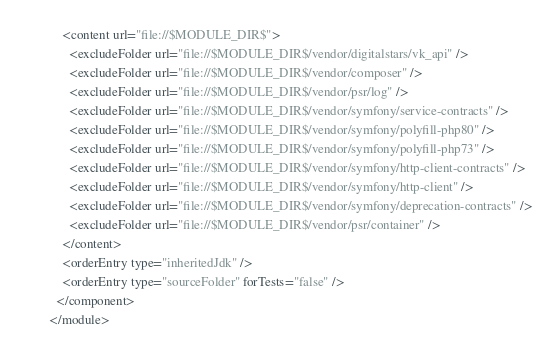Convert code to text. <code><loc_0><loc_0><loc_500><loc_500><_XML_>    <content url="file://$MODULE_DIR$">
      <excludeFolder url="file://$MODULE_DIR$/vendor/digitalstars/vk_api" />
      <excludeFolder url="file://$MODULE_DIR$/vendor/composer" />
      <excludeFolder url="file://$MODULE_DIR$/vendor/psr/log" />
      <excludeFolder url="file://$MODULE_DIR$/vendor/symfony/service-contracts" />
      <excludeFolder url="file://$MODULE_DIR$/vendor/symfony/polyfill-php80" />
      <excludeFolder url="file://$MODULE_DIR$/vendor/symfony/polyfill-php73" />
      <excludeFolder url="file://$MODULE_DIR$/vendor/symfony/http-client-contracts" />
      <excludeFolder url="file://$MODULE_DIR$/vendor/symfony/http-client" />
      <excludeFolder url="file://$MODULE_DIR$/vendor/symfony/deprecation-contracts" />
      <excludeFolder url="file://$MODULE_DIR$/vendor/psr/container" />
    </content>
    <orderEntry type="inheritedJdk" />
    <orderEntry type="sourceFolder" forTests="false" />
  </component>
</module></code> 